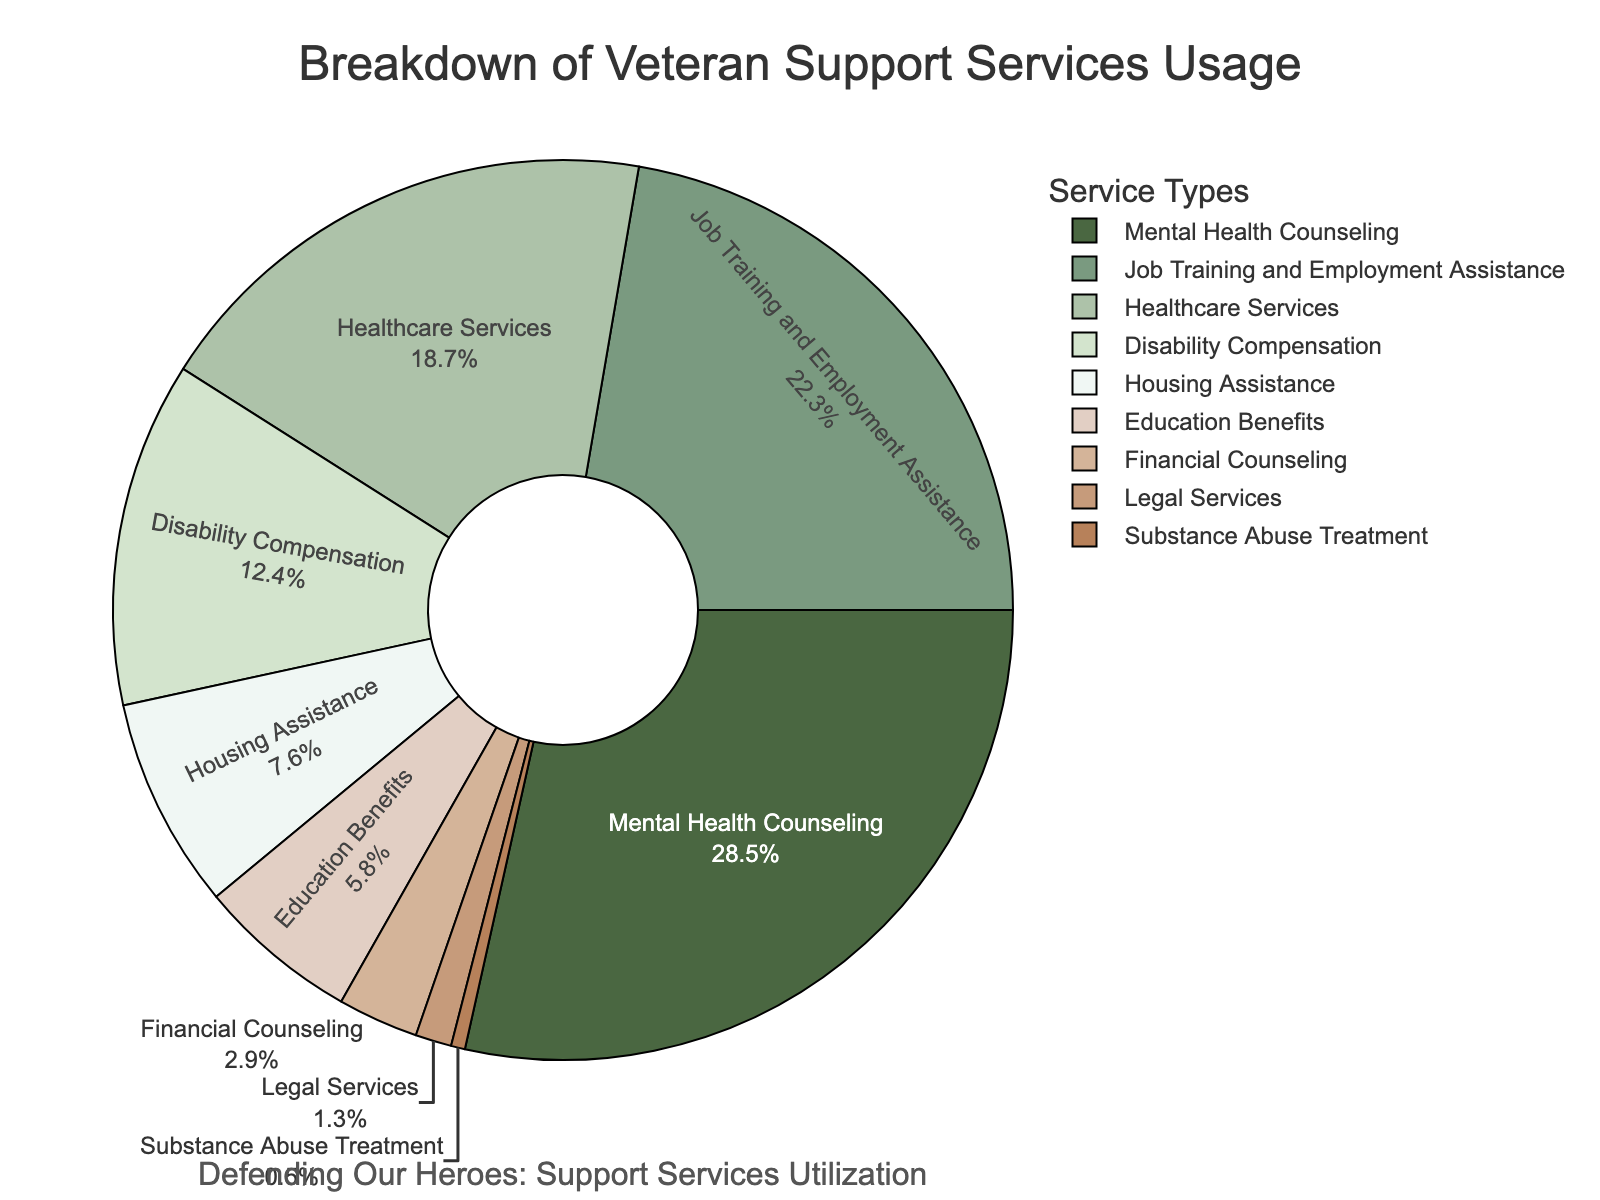Which service type has the highest usage percentage? The figure shows the breakdown of veteran support services usage by type of service. By looking at the percentages, Mental Health Counseling has the highest at 28.5%.
Answer: Mental Health Counseling What is the total percentage of services used related to employment and training? The services related to employment and training are "Job Training and Employment Assistance," which has a usage percentage of 22.3%.
Answer: 22.3% How does the usage of Healthcare Services compare to Disability Compensation? The usage percentage of Healthcare Services is 18.7%, while Disability Compensation has 12.4%. By comparing these, Healthcare Services usage is higher than Disability Compensation by 6.3%.
Answer: Healthcare Services has a 6.3% higher usage than Disability Compensation What is the combined usage percentage of Mental Health Counseling and Housing Assistance? The figure shows that Mental Health Counseling has a usage percentage of 28.5% and Housing Assistance has 7.6%. Adding these two together gives 28.5% + 7.6% = 36.1%.
Answer: 36.1% What is the smallest service usage category? By looking at the figure, the smallest service usage category is Substance Abuse Treatment with a percentage of 0.5%.
Answer: Substance Abuse Treatment Which service type occupies the lightest green section of the pie chart? The pie chart uses various shades of green for different sections. The lightest green section corresponds to Housing Assistance.
Answer: Housing Assistance What is the difference in usage percentage between Education Benefits and Financial Counseling? Education Benefits have a usage percentage of 5.8%, and Financial Counseling has 2.9%. The difference between these two percentages is 5.8% - 2.9% = 2.9%.
Answer: 2.9% What percentage of services usage is accounted for by Income support-related services (Disability Compensation + Financial Counseling)? Disability Compensation has a usage of 12.4% and Financial Counseling has 2.9%. Adding these together gives 12.4% + 2.9% = 15.3%.
Answer: 15.3% 